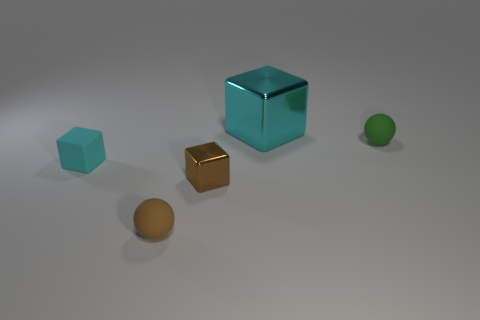The cube that is both behind the tiny metal thing and in front of the small green matte object is what color?
Make the answer very short. Cyan. Is the big block made of the same material as the brown cube?
Keep it short and to the point. Yes. There is a tiny metal thing; what shape is it?
Your answer should be compact. Cube. How many large shiny objects are to the left of the small matte thing on the left side of the brown thing that is left of the tiny metallic thing?
Your answer should be very brief. 0. What color is the other rubber object that is the same shape as the green object?
Provide a short and direct response. Brown. There is a small matte thing on the right side of the rubber ball that is on the left side of the green matte object that is behind the brown shiny thing; what shape is it?
Your answer should be very brief. Sphere. There is a thing that is both on the left side of the small brown block and behind the brown sphere; what size is it?
Offer a very short reply. Small. Are there fewer small matte blocks than large green shiny cylinders?
Provide a succinct answer. No. There is a brown matte thing left of the green rubber ball; how big is it?
Ensure brevity in your answer.  Small. There is a object that is both behind the small matte cube and in front of the large cyan object; what shape is it?
Ensure brevity in your answer.  Sphere. 